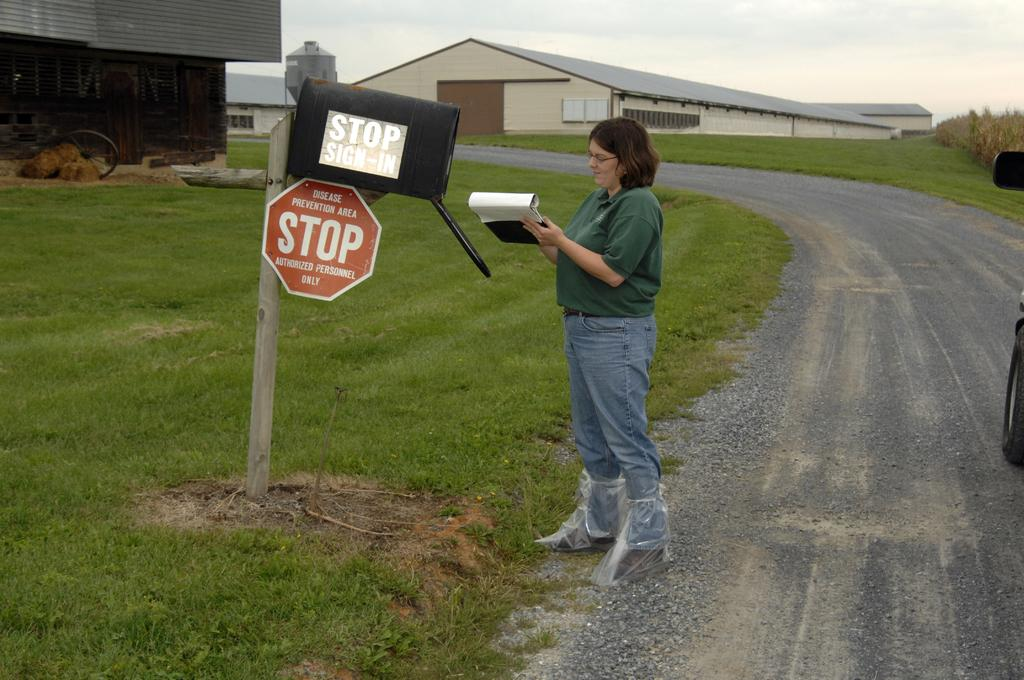<image>
Summarize the visual content of the image. A woman looks at a piece of paper on a clipboard next to a mailbox that reads STOP SIGN-IN 